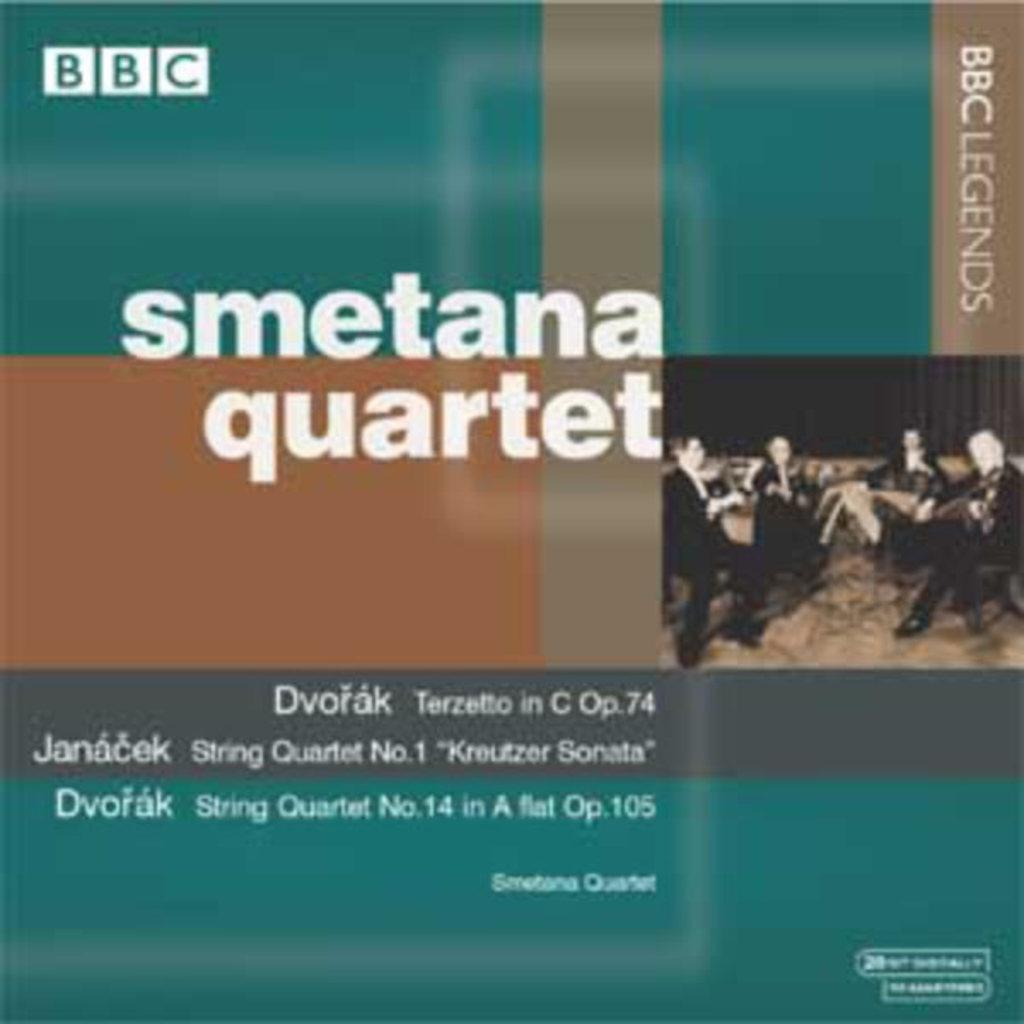What is featured on the poster in the image? There is a poster in the image, which contains a group of people. What are the people on the poster doing? The people on the poster are sitting and playing musical instruments. Is there any text on the poster? Yes, there is text on the poster. Can you see a volleyball game happening in the image? No, there is no volleyball game present in the image. Is the earth visible in the image? No, the earth is not visible in the image; it features a poster with people playing musical instruments. 